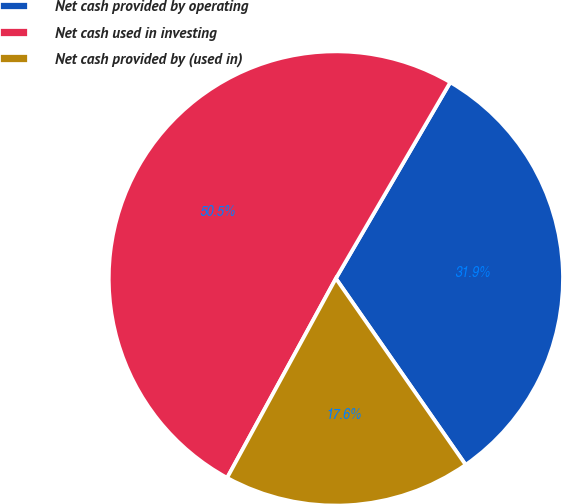Convert chart. <chart><loc_0><loc_0><loc_500><loc_500><pie_chart><fcel>Net cash provided by operating<fcel>Net cash used in investing<fcel>Net cash provided by (used in)<nl><fcel>31.92%<fcel>50.46%<fcel>17.63%<nl></chart> 